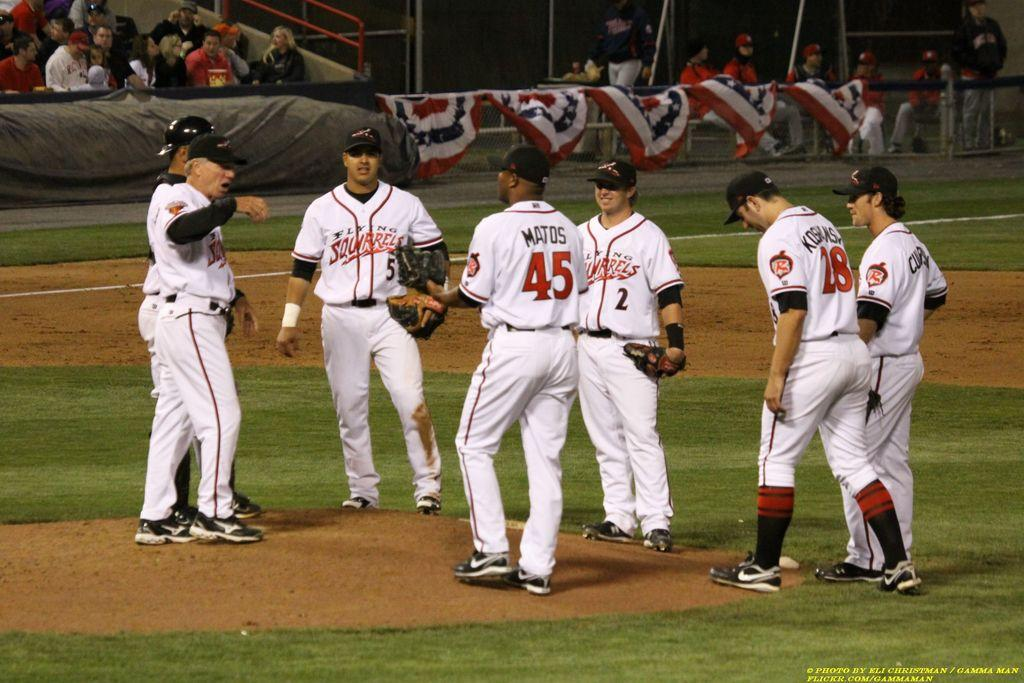Provide a one-sentence caption for the provided image. Player number 5 for the Flying Squirrels stands with his teammates on the pitchers mound. 